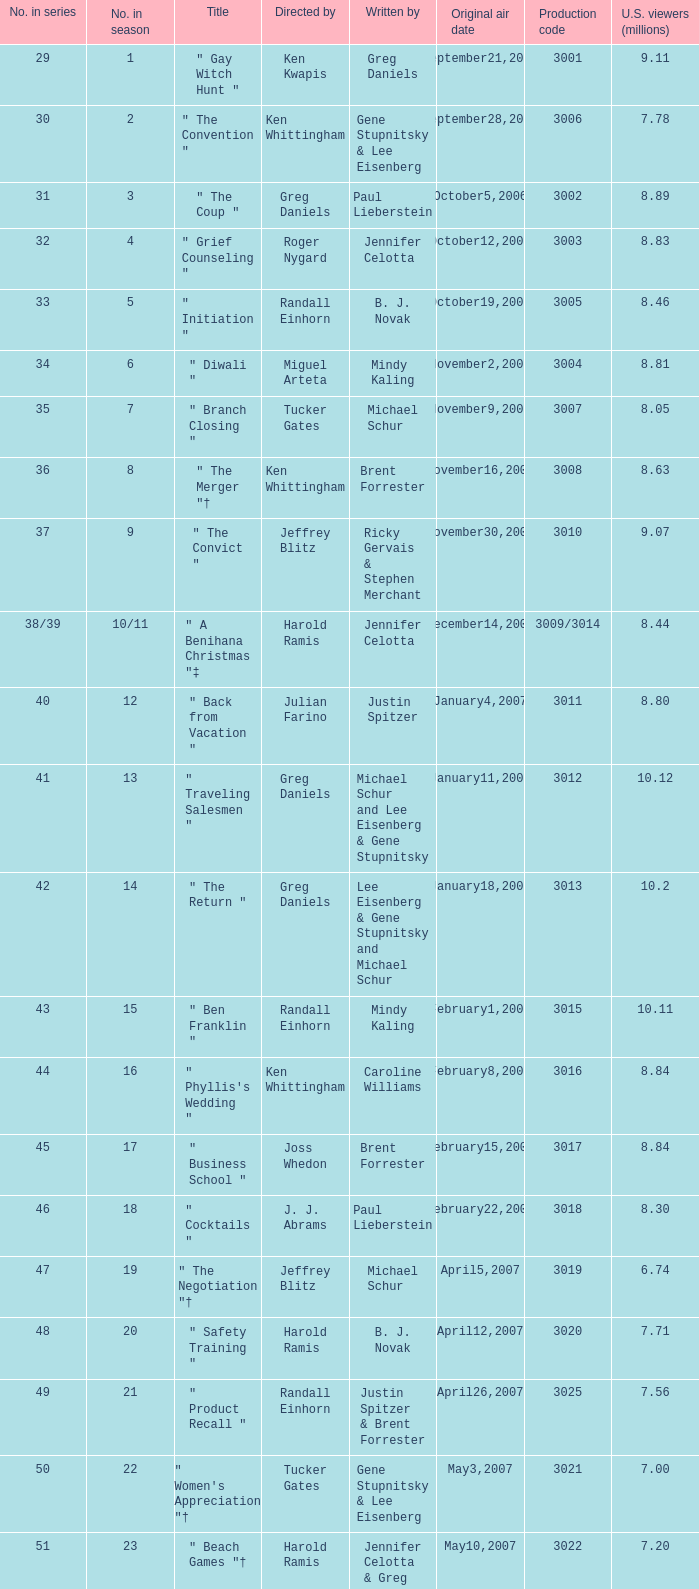What is the value in the sequence when the viewers are 7.78? 30.0. 